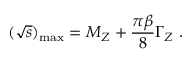<formula> <loc_0><loc_0><loc_500><loc_500>( \sqrt { s } ) _ { \max } = M _ { Z } + \frac { \pi \beta } { 8 } \Gamma _ { Z } .</formula> 